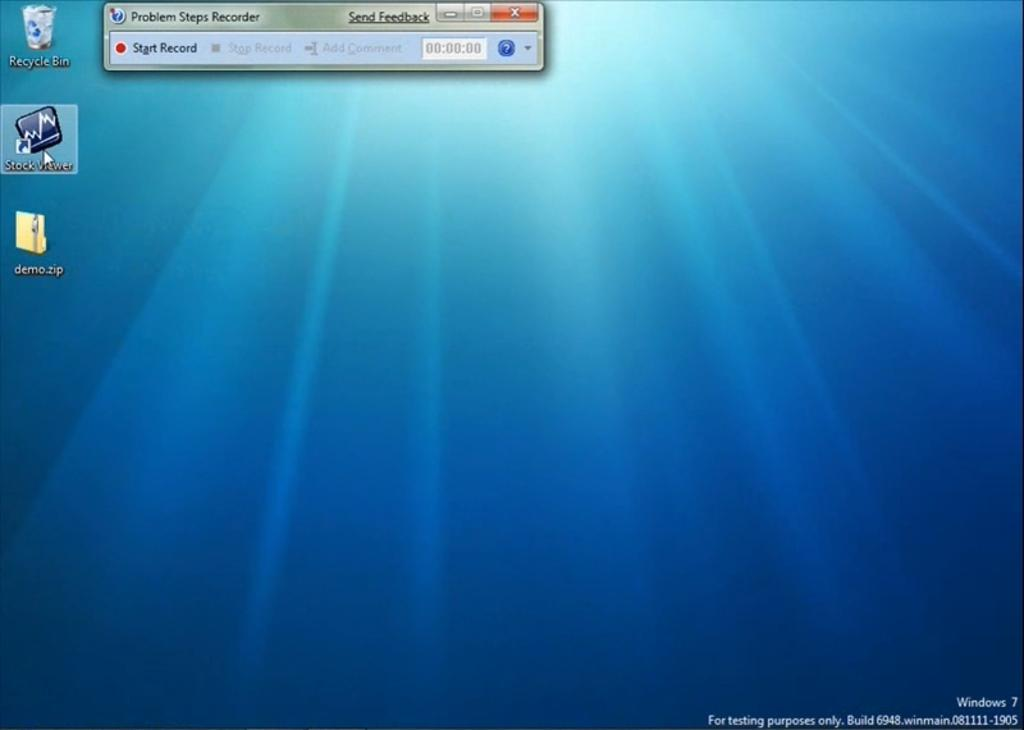<image>
Create a compact narrative representing the image presented. A screenshot of a computer desktop with an app called stock viewer selected. 